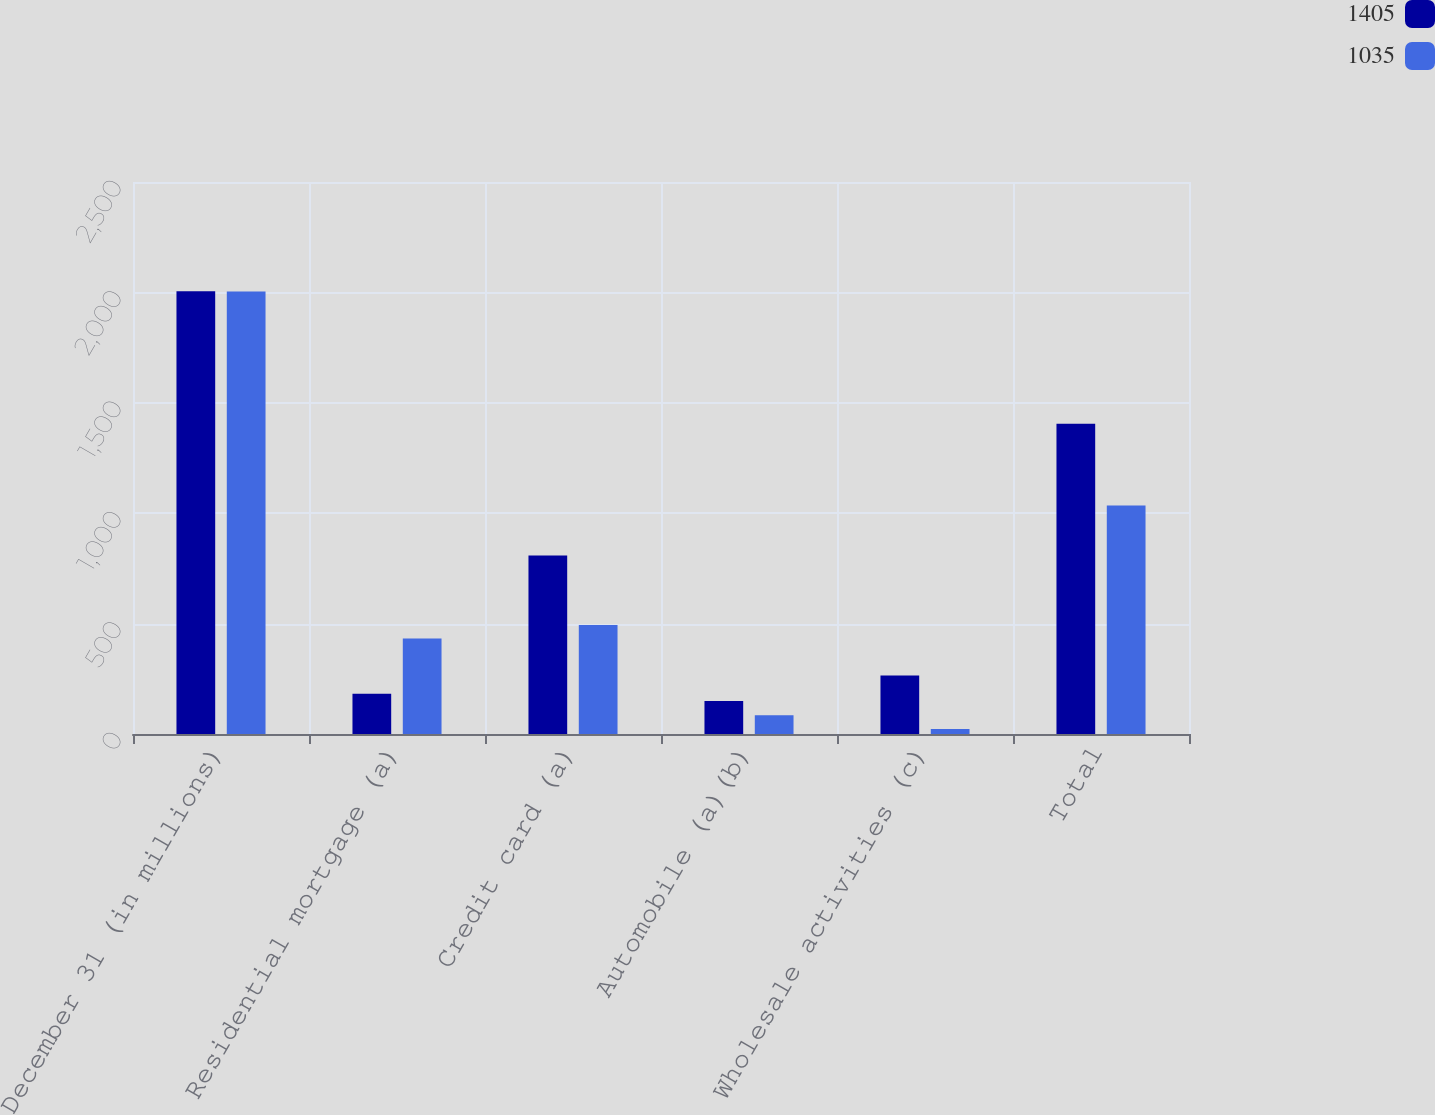<chart> <loc_0><loc_0><loc_500><loc_500><stacked_bar_chart><ecel><fcel>December 31 (in millions)<fcel>Residential mortgage (a)<fcel>Credit card (a)<fcel>Automobile (a)(b)<fcel>Wholesale activities (c)<fcel>Total<nl><fcel>1405<fcel>2005<fcel>182<fcel>808<fcel>150<fcel>265<fcel>1405<nl><fcel>1035<fcel>2004<fcel>433<fcel>494<fcel>85<fcel>23<fcel>1035<nl></chart> 